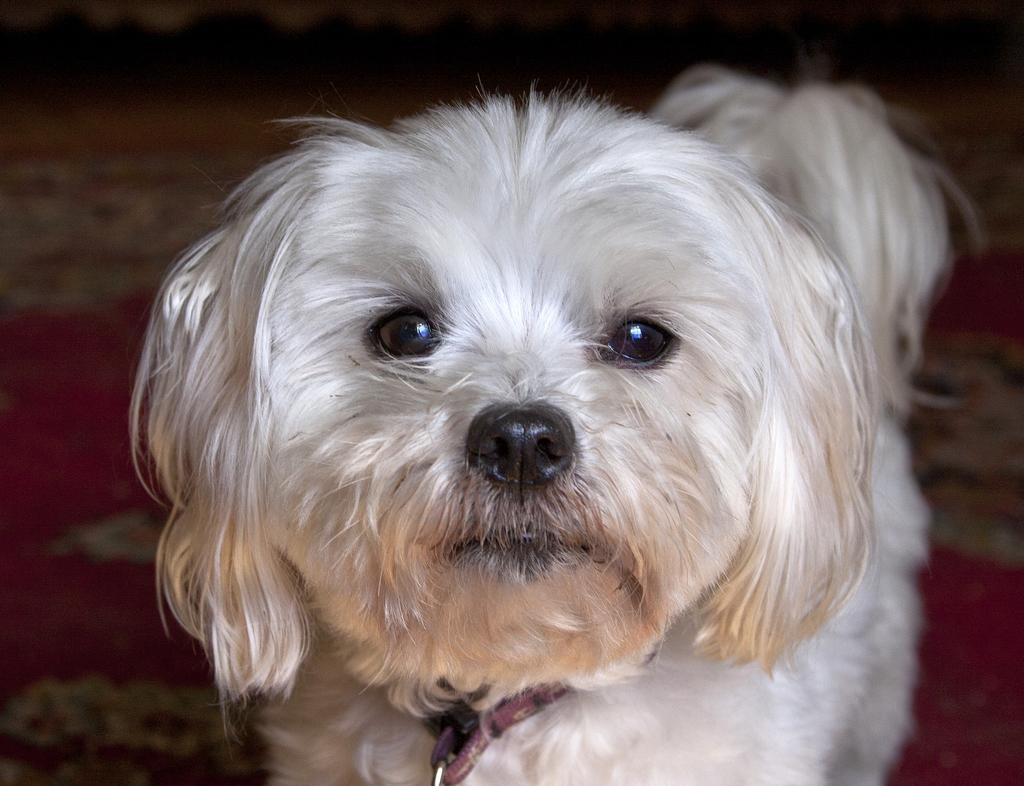What type of animal is in the image? There is a dog in the image. What color is the dog? The dog is white. Where is the dog located in the image? The dog is in the foreground of the image. How is the dog depicted in the image? The dog is blurred in the background. Is the dog driving a car in the image? No, the dog is not driving a car in the image; it is a static image of a dog. Can you see a pig in the image? No, there is no pig present in the image; it only features a white dog. 